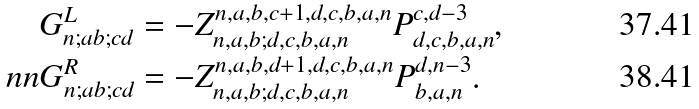<formula> <loc_0><loc_0><loc_500><loc_500>G _ { n ; a b ; c d } ^ { L } & = - Z _ { n , a , b ; d , c , b , a , n } ^ { n , a , b , c + 1 , d , c , b , a , n } P _ { d , c , b , a , n } ^ { c , d - 3 } , \\ \ n n G _ { n ; a b ; c d } ^ { R } & = - Z _ { n , a , b ; d , c , b , a , n } ^ { n , a , b , d + 1 , d , c , b , a , n } P _ { b , a , n } ^ { d , n - 3 } .</formula> 